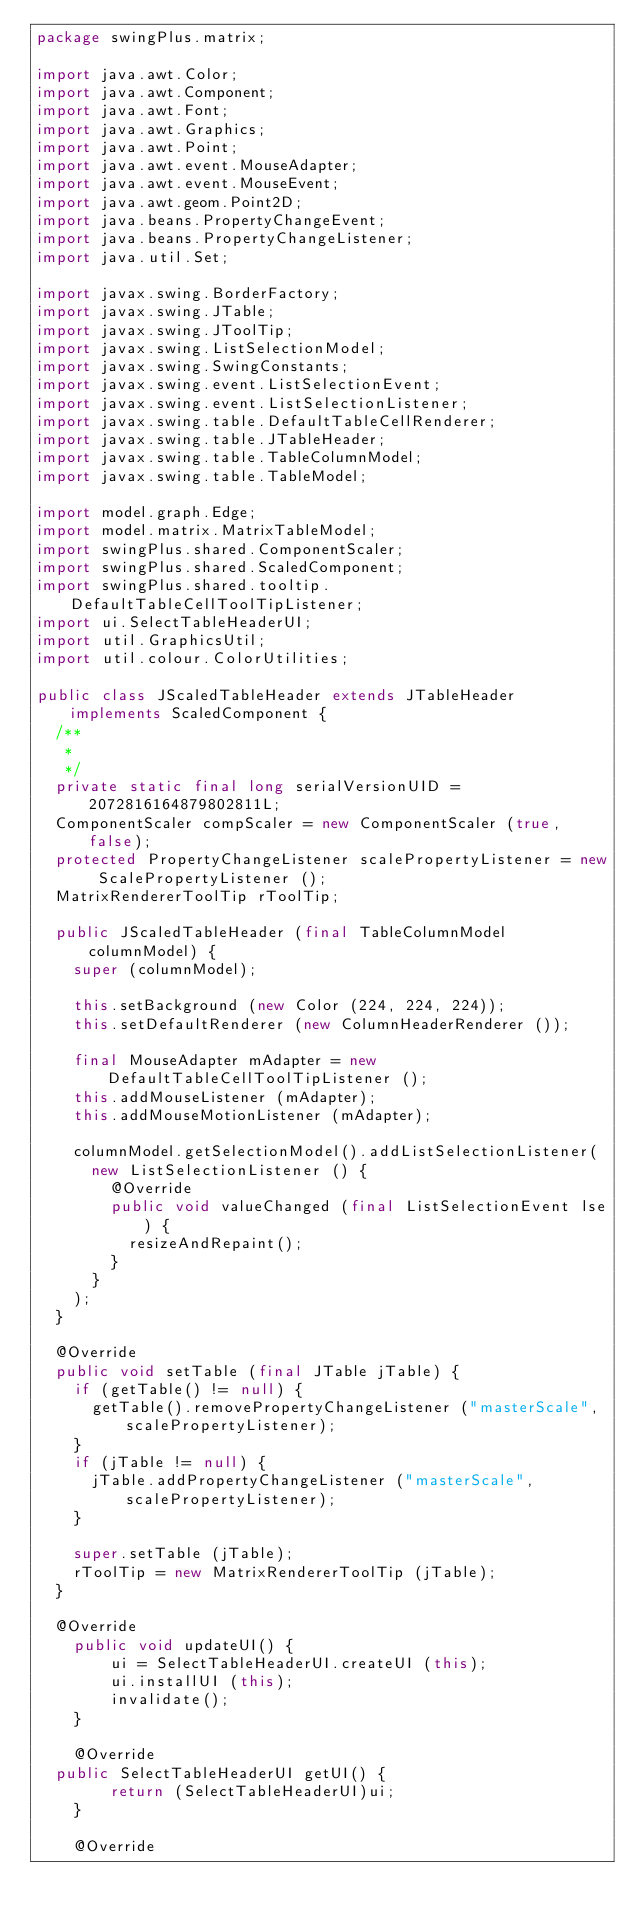Convert code to text. <code><loc_0><loc_0><loc_500><loc_500><_Java_>package swingPlus.matrix;

import java.awt.Color;
import java.awt.Component;
import java.awt.Font;
import java.awt.Graphics;
import java.awt.Point;
import java.awt.event.MouseAdapter;
import java.awt.event.MouseEvent;
import java.awt.geom.Point2D;
import java.beans.PropertyChangeEvent;
import java.beans.PropertyChangeListener;
import java.util.Set;

import javax.swing.BorderFactory;
import javax.swing.JTable;
import javax.swing.JToolTip;
import javax.swing.ListSelectionModel;
import javax.swing.SwingConstants;
import javax.swing.event.ListSelectionEvent;
import javax.swing.event.ListSelectionListener;
import javax.swing.table.DefaultTableCellRenderer;
import javax.swing.table.JTableHeader;
import javax.swing.table.TableColumnModel;
import javax.swing.table.TableModel;

import model.graph.Edge;
import model.matrix.MatrixTableModel;
import swingPlus.shared.ComponentScaler;
import swingPlus.shared.ScaledComponent;
import swingPlus.shared.tooltip.DefaultTableCellToolTipListener;
import ui.SelectTableHeaderUI;
import util.GraphicsUtil;
import util.colour.ColorUtilities;

public class JScaledTableHeader extends JTableHeader implements ScaledComponent {
	/**
	 * 
	 */
	private static final long serialVersionUID = 2072816164879802811L;
	ComponentScaler compScaler = new ComponentScaler (true, false);
	protected PropertyChangeListener scalePropertyListener = new ScalePropertyListener ();
	MatrixRendererToolTip rToolTip;
	
	public JScaledTableHeader (final TableColumnModel columnModel) {
		super (columnModel);
		
		this.setBackground (new Color (224, 224, 224));
		this.setDefaultRenderer (new ColumnHeaderRenderer ());	

		final MouseAdapter mAdapter = new DefaultTableCellToolTipListener ();
		this.addMouseListener (mAdapter);
		this.addMouseMotionListener (mAdapter);
		
		columnModel.getSelectionModel().addListSelectionListener(
			new ListSelectionListener () {
				@Override
				public void valueChanged (final ListSelectionEvent lse) {
					resizeAndRepaint();
				}	
			}
		);
	}
	
	@Override
	public void setTable (final JTable jTable) {
		if (getTable() != null) {
			getTable().removePropertyChangeListener ("masterScale", scalePropertyListener);
		}
		if (jTable != null) {
			jTable.addPropertyChangeListener ("masterScale", scalePropertyListener);
		}
		
		super.setTable (jTable);
		rToolTip = new MatrixRendererToolTip (jTable);
	}
	
	@Override
    public void updateUI() {
        ui = SelectTableHeaderUI.createUI (this);
        ui.installUI (this);
        invalidate();
    }

    @Override
	public SelectTableHeaderUI getUI() {
        return (SelectTableHeaderUI)ui;
    }

    @Override</code> 